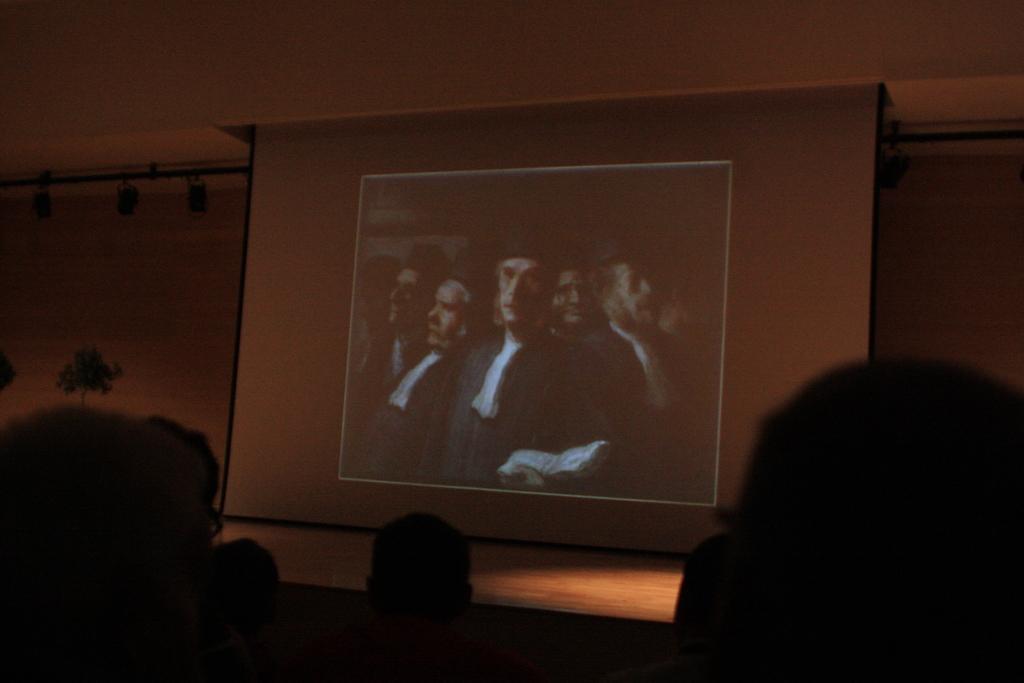Could you give a brief overview of what you see in this image? In this image we can see some people sitting and they are watching a movie on the projector screen. 